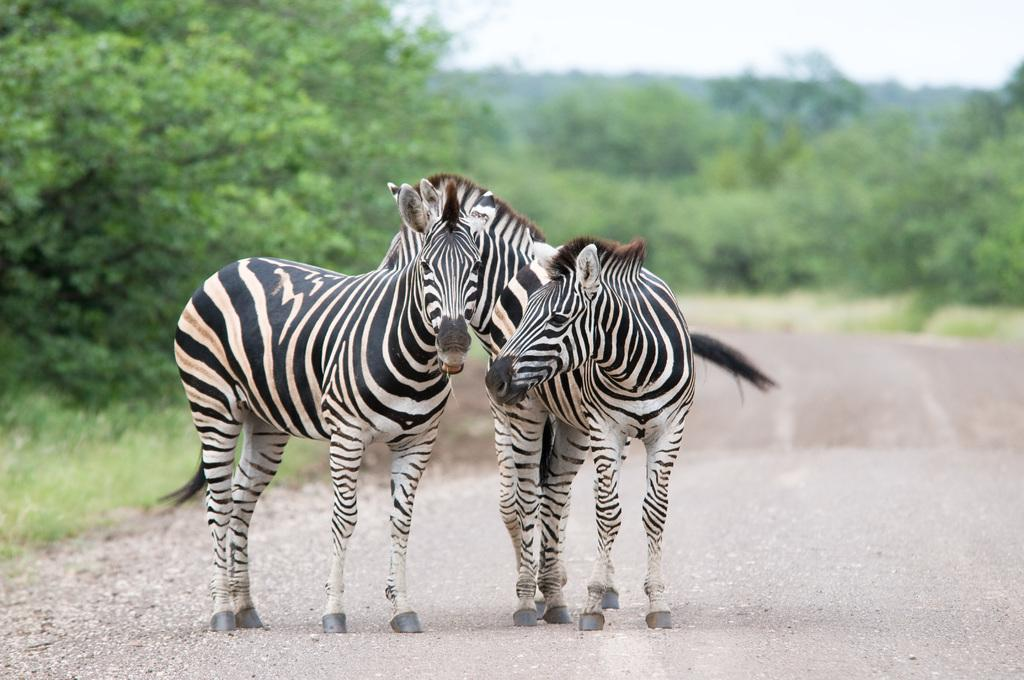What animals can be seen in the image? There are zebras in the image. Where are the zebras located? The zebras are on the road. What can be seen in the background of the image? The sky, clouds, trees, and grass are visible in the background of the image. How many toes does each zebra have in the image? The number of toes on each zebra cannot be determined from the image, as it does not show the zebras' feet. 